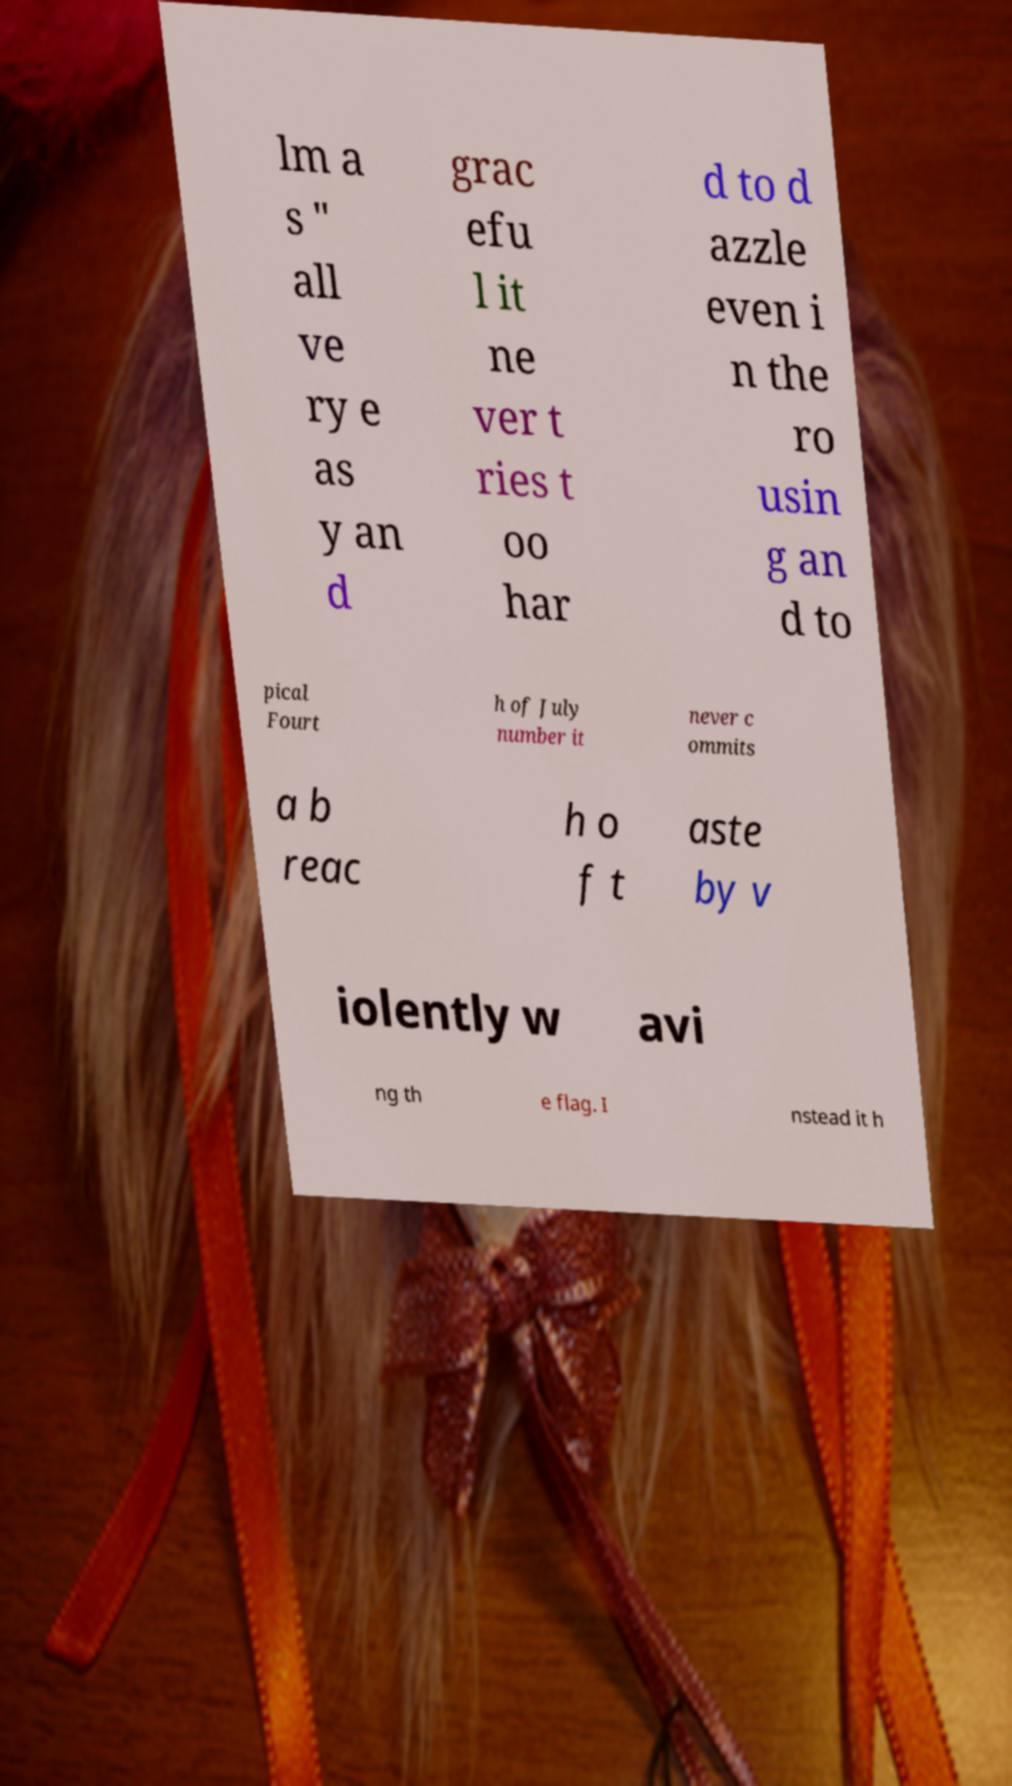Can you accurately transcribe the text from the provided image for me? lm a s " all ve ry e as y an d grac efu l it ne ver t ries t oo har d to d azzle even i n the ro usin g an d to pical Fourt h of July number it never c ommits a b reac h o f t aste by v iolently w avi ng th e flag. I nstead it h 